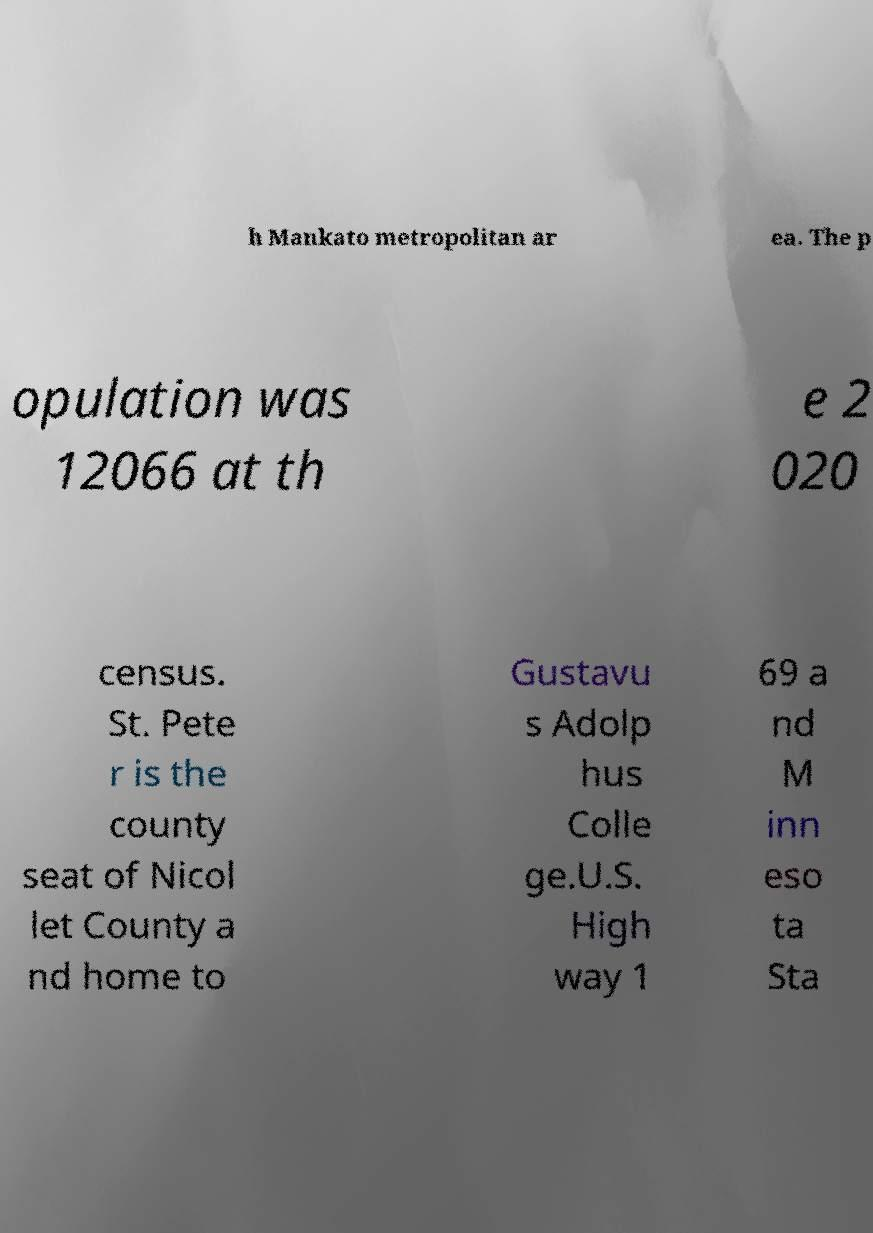For documentation purposes, I need the text within this image transcribed. Could you provide that? h Mankato metropolitan ar ea. The p opulation was 12066 at th e 2 020 census. St. Pete r is the county seat of Nicol let County a nd home to Gustavu s Adolp hus Colle ge.U.S. High way 1 69 a nd M inn eso ta Sta 